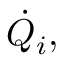<formula> <loc_0><loc_0><loc_500><loc_500>{ \dot { Q } } _ { i } ,</formula> 